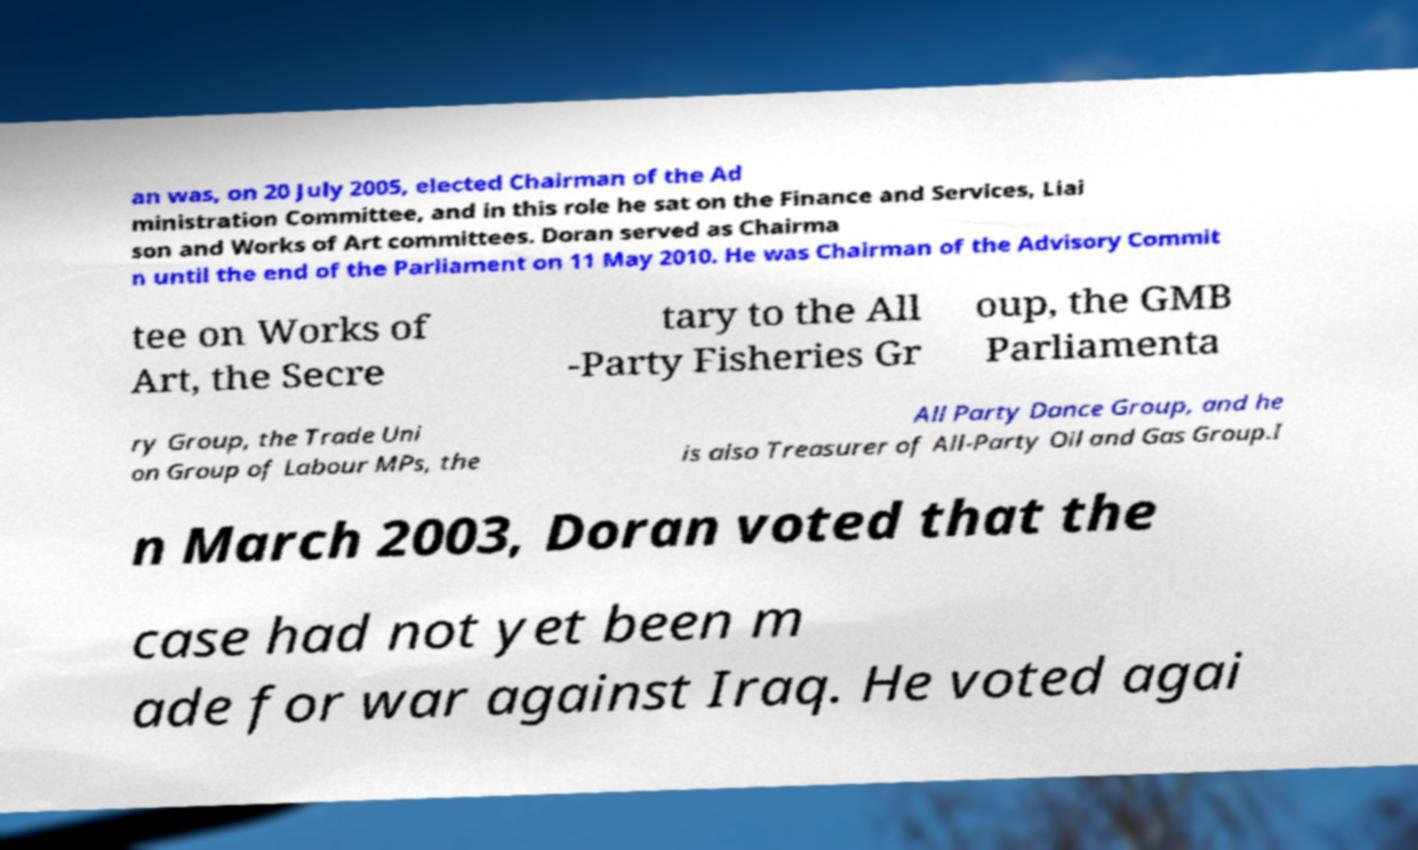Could you extract and type out the text from this image? an was, on 20 July 2005, elected Chairman of the Ad ministration Committee, and in this role he sat on the Finance and Services, Liai son and Works of Art committees. Doran served as Chairma n until the end of the Parliament on 11 May 2010. He was Chairman of the Advisory Commit tee on Works of Art, the Secre tary to the All -Party Fisheries Gr oup, the GMB Parliamenta ry Group, the Trade Uni on Group of Labour MPs, the All Party Dance Group, and he is also Treasurer of All-Party Oil and Gas Group.I n March 2003, Doran voted that the case had not yet been m ade for war against Iraq. He voted agai 